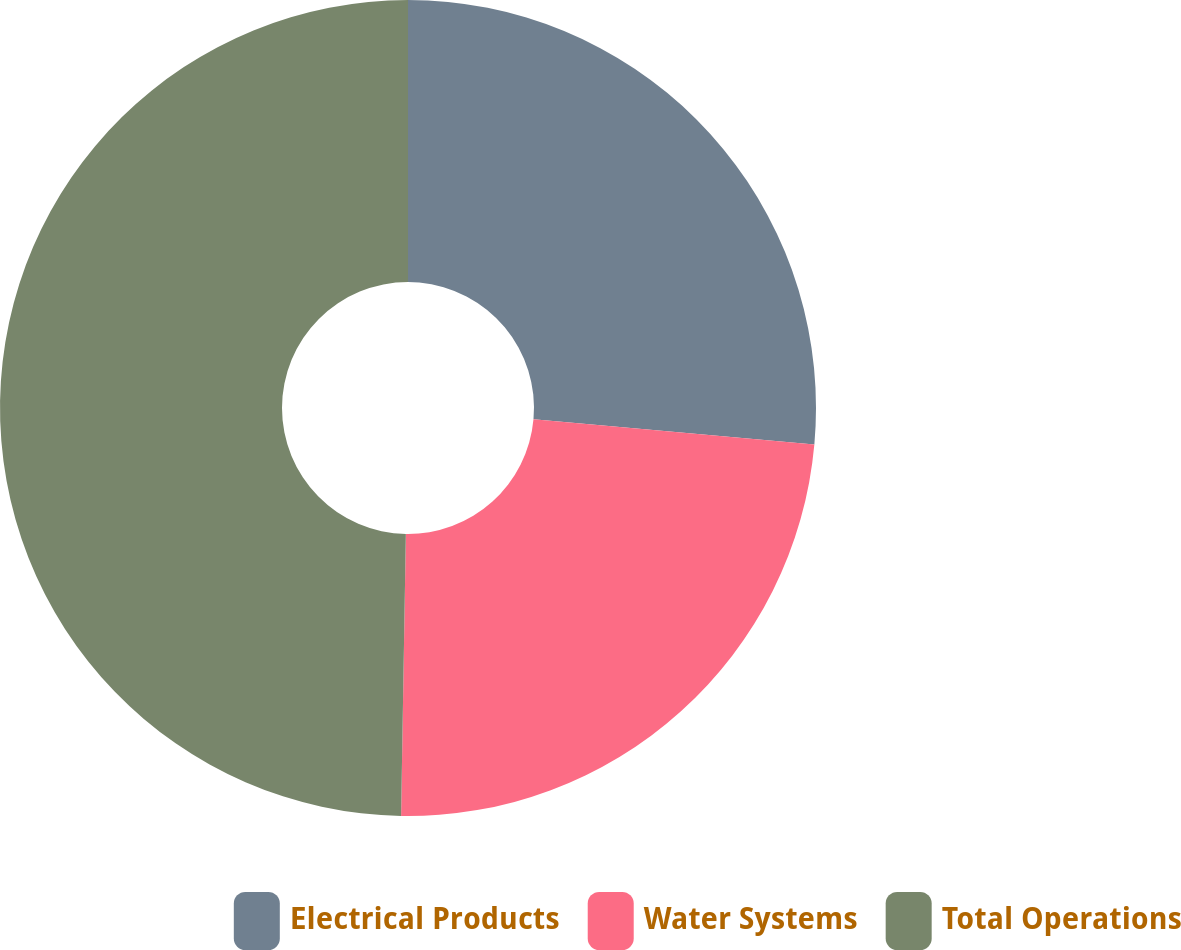<chart> <loc_0><loc_0><loc_500><loc_500><pie_chart><fcel>Electrical Products<fcel>Water Systems<fcel>Total Operations<nl><fcel>26.43%<fcel>23.84%<fcel>49.73%<nl></chart> 